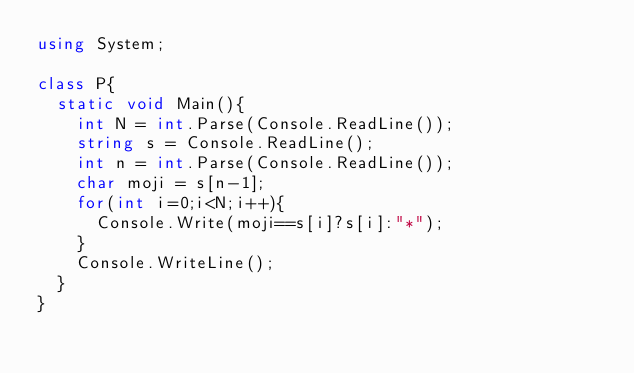<code> <loc_0><loc_0><loc_500><loc_500><_C#_>using System;

class P{
  static void Main(){
    int N = int.Parse(Console.ReadLine());
    string s = Console.ReadLine();
    int n = int.Parse(Console.ReadLine());
    char moji = s[n-1];
    for(int i=0;i<N;i++){
      Console.Write(moji==s[i]?s[i]:"*");
    }
    Console.WriteLine();
  }
}</code> 